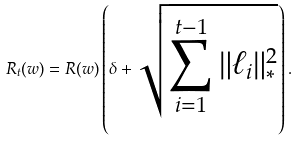Convert formula to latex. <formula><loc_0><loc_0><loc_500><loc_500>R _ { t } ( w ) = R ( w ) \left ( \delta + \sqrt { \sum _ { i = 1 } ^ { t - 1 } \| \ell _ { i } \| _ { * } ^ { 2 } } \right ) .</formula> 